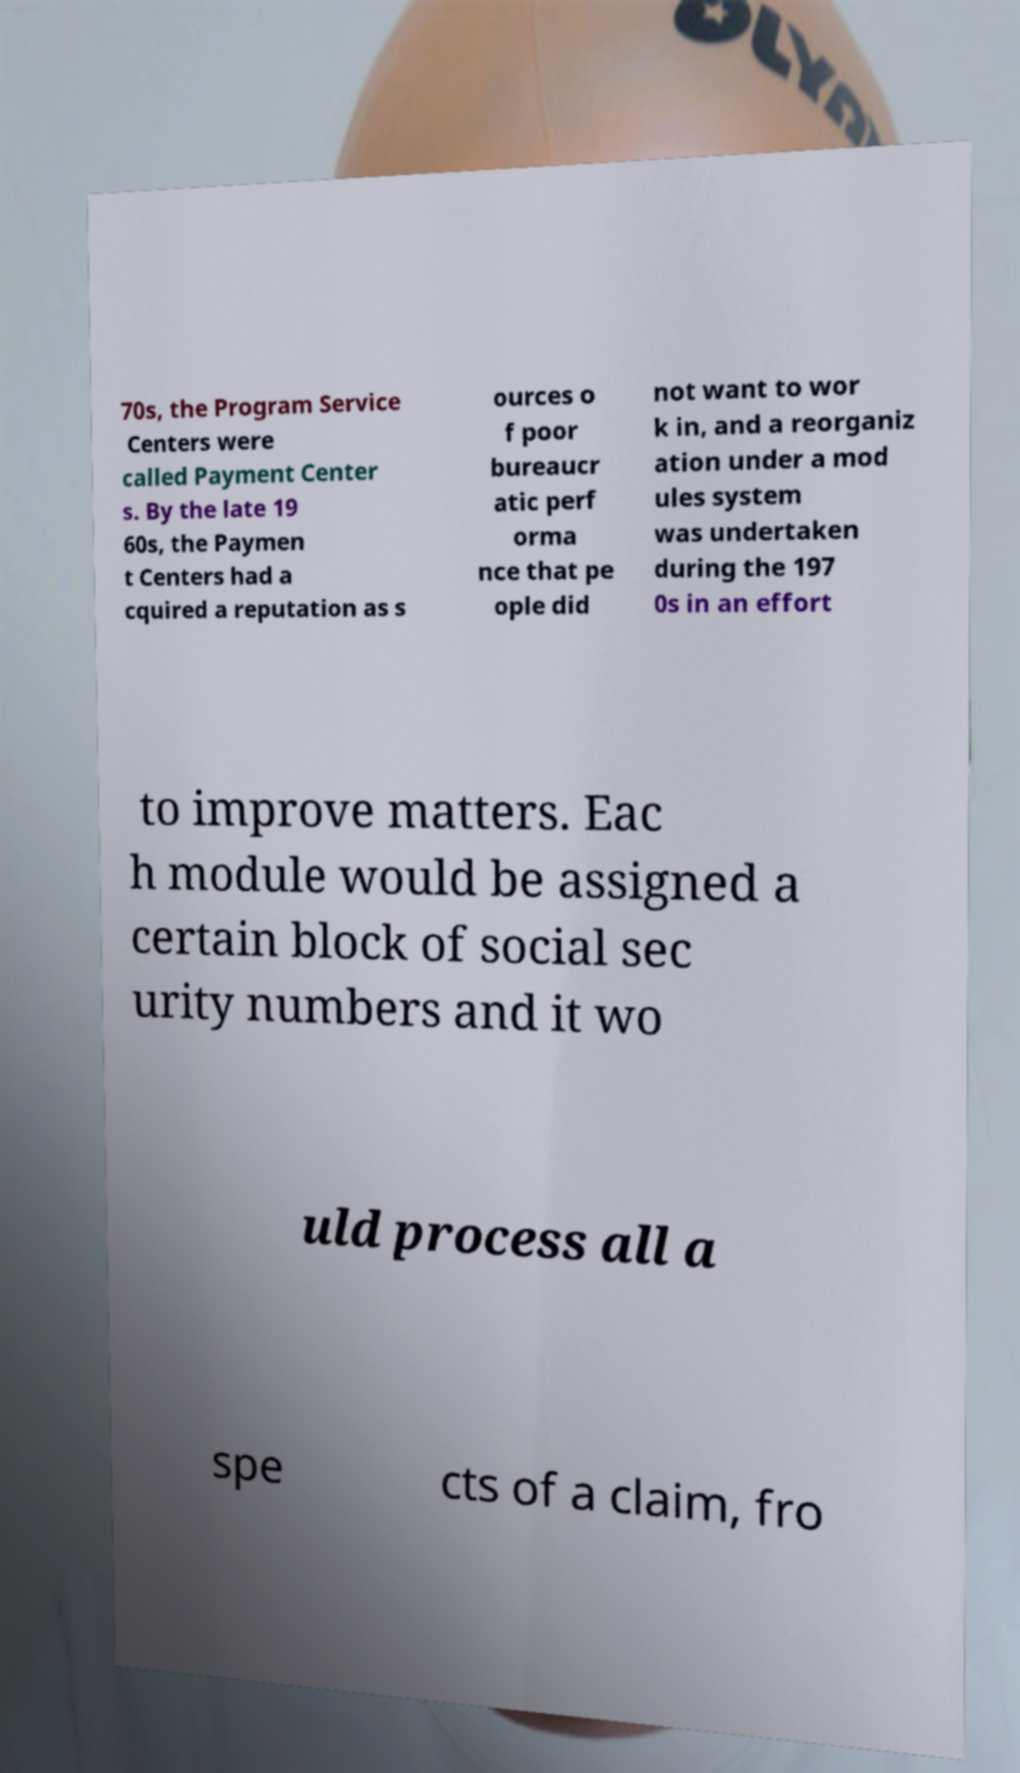What messages or text are displayed in this image? I need them in a readable, typed format. 70s, the Program Service Centers were called Payment Center s. By the late 19 60s, the Paymen t Centers had a cquired a reputation as s ources o f poor bureaucr atic perf orma nce that pe ople did not want to wor k in, and a reorganiz ation under a mod ules system was undertaken during the 197 0s in an effort to improve matters. Eac h module would be assigned a certain block of social sec urity numbers and it wo uld process all a spe cts of a claim, fro 